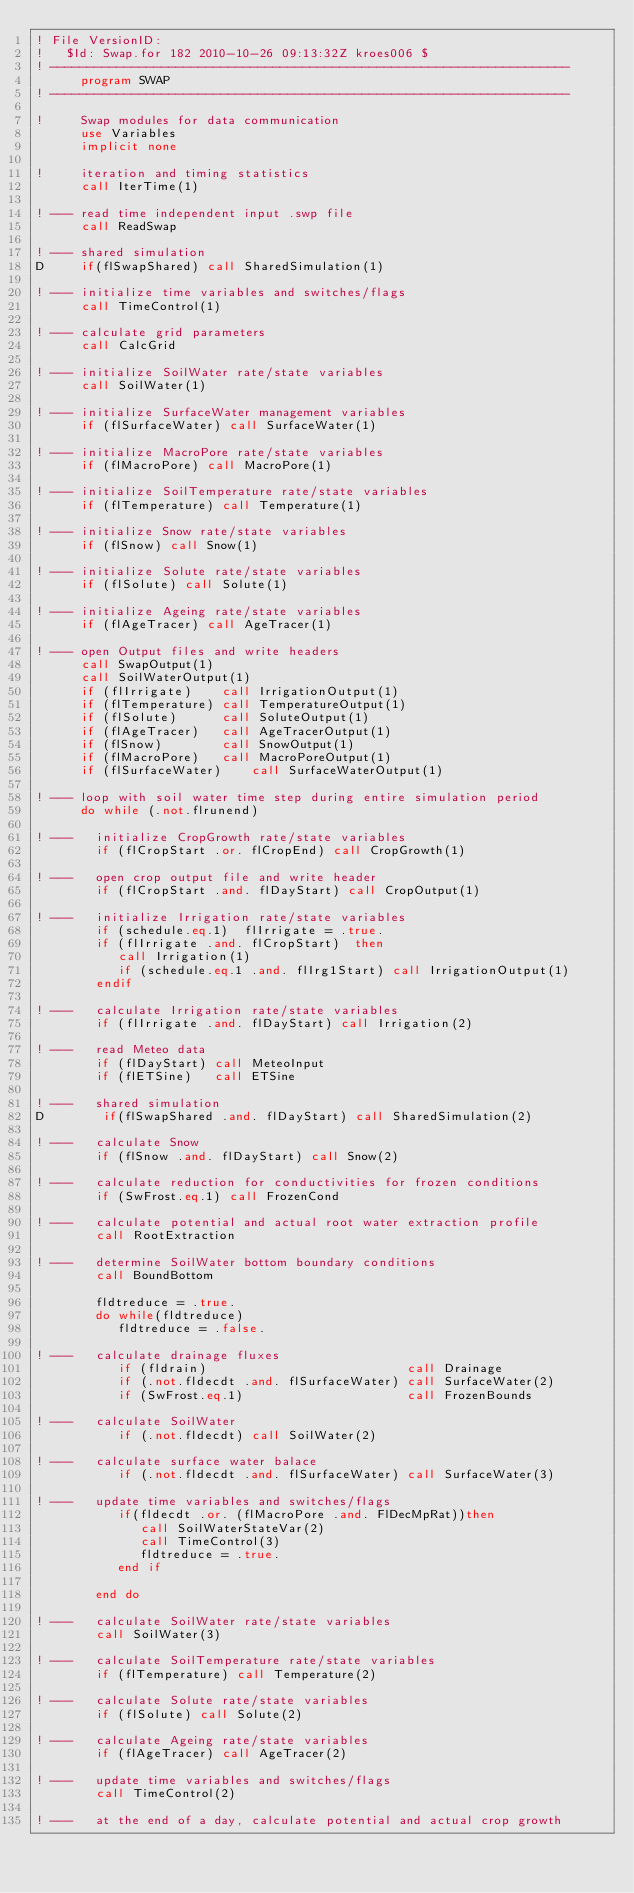Convert code to text. <code><loc_0><loc_0><loc_500><loc_500><_FORTRAN_>! File VersionID:
!   $Id: Swap.for 182 2010-10-26 09:13:32Z kroes006 $
! ----------------------------------------------------------------------
      program SWAP
! ----------------------------------------------------------------------

!     Swap modules for data communication
      use Variables
      implicit none

!     iteration and timing statistics
      call IterTime(1)

! --- read time independent input .swp file
      call ReadSwap

! --- shared simulation
D     if(flSwapShared) call SharedSimulation(1)

! --- initialize time variables and switches/flags
      call TimeControl(1)

! --- calculate grid parameters
      call CalcGrid

! --- initialize SoilWater rate/state variables 
      call SoilWater(1)

! --- initialize SurfaceWater management variables
      if (flSurfaceWater) call SurfaceWater(1)

! --- initialize MacroPore rate/state variables
      if (flMacroPore) call MacroPore(1)

! --- initialize SoilTemperature rate/state variables
      if (flTemperature) call Temperature(1)

! --- initialize Snow rate/state variables
      if (flSnow) call Snow(1)

! --- initialize Solute rate/state variables
      if (flSolute) call Solute(1)

! --- initialize Ageing rate/state variables
      if (flAgeTracer) call AgeTracer(1)

! --- open Output files and write headers
      call SwapOutput(1)
      call SoilWaterOutput(1)
      if (flIrrigate)    call IrrigationOutput(1)
      if (flTemperature) call TemperatureOutput(1)
      if (flSolute)      call SoluteOutput(1)
      if (flAgeTracer)   call AgeTracerOutput(1)
      if (flSnow)        call SnowOutput(1)
      if (flMacroPore)   call MacroPoreOutput(1)
      if (flSurfaceWater)    call SurfaceWaterOutput(1)

! --- loop with soil water time step during entire simulation period
      do while (.not.flrunend)

! ---   initialize CropGrowth rate/state variables
        if (flCropStart .or. flCropEnd) call CropGrowth(1)

! ---   open crop output file and write header
        if (flCropStart .and. flDayStart) call CropOutput(1)

! ---   initialize Irrigation rate/state variables
        if (schedule.eq.1)  flIrrigate = .true.
        if (flIrrigate .and. flCropStart)  then
           call Irrigation(1)
           if (schedule.eq.1 .and. flIrg1Start) call IrrigationOutput(1)
        endif

! ---   calculate Irrigation rate/state variables
        if (flIrrigate .and. flDayStart) call Irrigation(2)

! ---   read Meteo data
        if (flDayStart) call MeteoInput
        if (flETSine)   call ETSine

! ---   shared simulation
D        if(flSwapShared .and. flDayStart) call SharedSimulation(2)

! ---   calculate Snow
        if (flSnow .and. flDayStart) call Snow(2)

! ---   calculate reduction for conductivities for frozen conditions
        if (SwFrost.eq.1) call FrozenCond
 
! ---   calculate potential and actual root water extraction profile
        call RootExtraction

! ---   determine SoilWater bottom boundary conditions
        call BoundBottom

        fldtreduce = .true.
        do while(fldtreduce)
           fldtreduce = .false.

! ---   calculate drainage fluxes
           if (fldrain)                           call Drainage
           if (.not.fldecdt .and. flSurfaceWater) call SurfaceWater(2)
           if (SwFrost.eq.1)                      call FrozenBounds
      
! ---   calculate SoilWater 
           if (.not.fldecdt) call SoilWater(2)

! ---   calculate surface water balace
           if (.not.fldecdt .and. flSurfaceWater) call SurfaceWater(3)

! ---   update time variables and switches/flags
           if(fldecdt .or. (flMacroPore .and. FlDecMpRat))then
              call SoilWaterStateVar(2)
              call TimeControl(3)
              fldtreduce = .true.
           end if

        end do

! ---   calculate SoilWater rate/state variables
        call SoilWater(3)

! ---   calculate SoilTemperature rate/state variables
        if (flTemperature) call Temperature(2)
           
! ---   calculate Solute rate/state variables
        if (flSolute) call Solute(2)

! ---   calculate Ageing rate/state variables
        if (flAgeTracer) call AgeTracer(2)

! ---   update time variables and switches/flags
        call TimeControl(2)

! ---   at the end of a day, calculate potential and actual crop growth </code> 